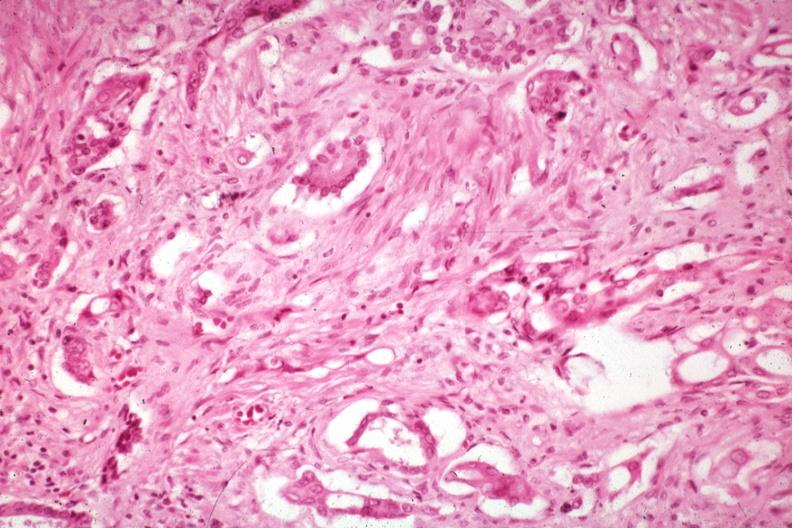what is present?
Answer the question using a single word or phrase. Pancreas 